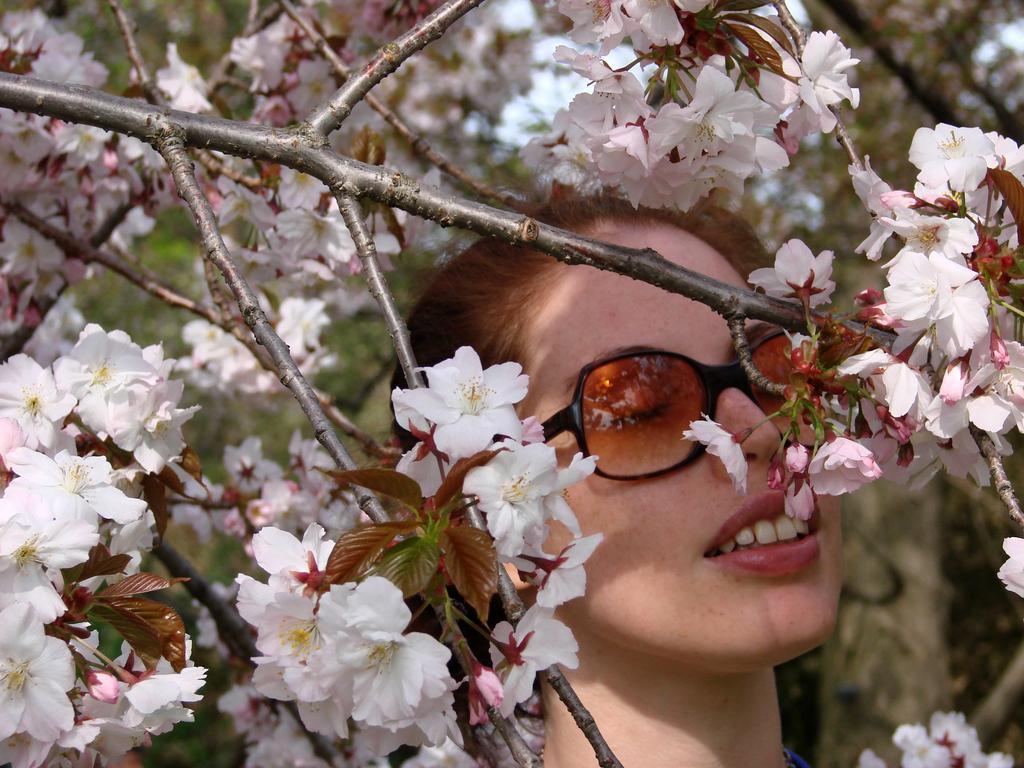Can you describe this image briefly? There is a lady in the center of the image she is wearing sun glasses, there are flowers around the area and there are trees and sky in the background area. 